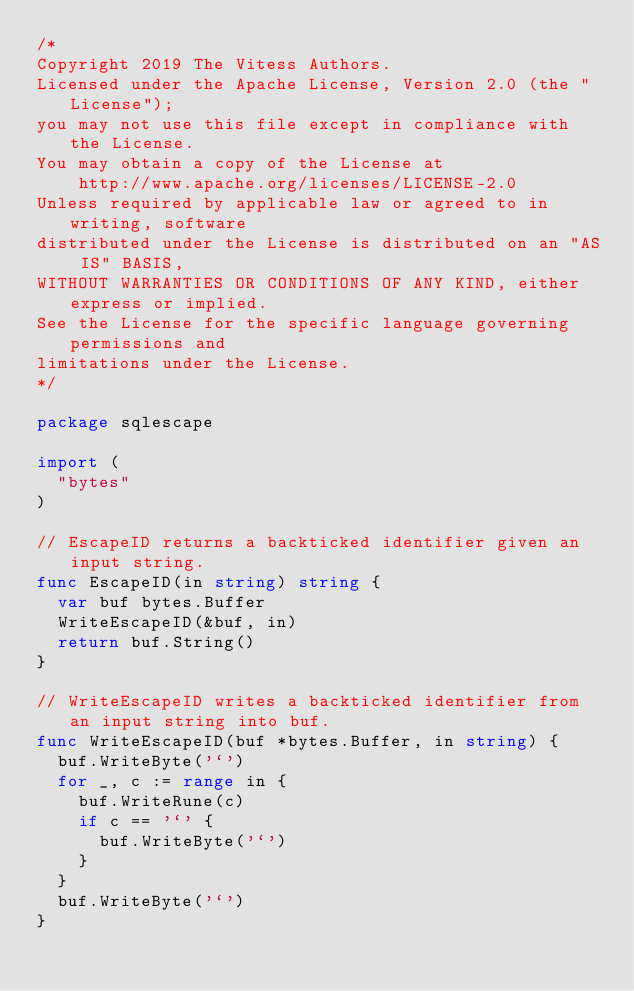Convert code to text. <code><loc_0><loc_0><loc_500><loc_500><_Go_>/*
Copyright 2019 The Vitess Authors.
Licensed under the Apache License, Version 2.0 (the "License");
you may not use this file except in compliance with the License.
You may obtain a copy of the License at
    http://www.apache.org/licenses/LICENSE-2.0
Unless required by applicable law or agreed to in writing, software
distributed under the License is distributed on an "AS IS" BASIS,
WITHOUT WARRANTIES OR CONDITIONS OF ANY KIND, either express or implied.
See the License for the specific language governing permissions and
limitations under the License.
*/

package sqlescape

import (
	"bytes"
)

// EscapeID returns a backticked identifier given an input string.
func EscapeID(in string) string {
	var buf bytes.Buffer
	WriteEscapeID(&buf, in)
	return buf.String()
}

// WriteEscapeID writes a backticked identifier from an input string into buf.
func WriteEscapeID(buf *bytes.Buffer, in string) {
	buf.WriteByte('`')
	for _, c := range in {
		buf.WriteRune(c)
		if c == '`' {
			buf.WriteByte('`')
		}
	}
	buf.WriteByte('`')
}
</code> 